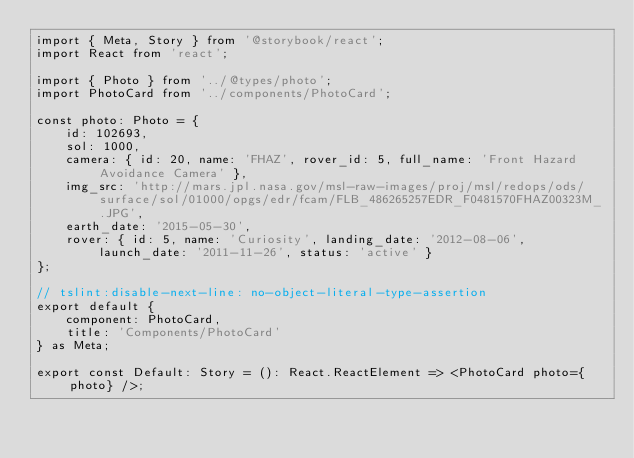<code> <loc_0><loc_0><loc_500><loc_500><_TypeScript_>import { Meta, Story } from '@storybook/react';
import React from 'react';

import { Photo } from '../@types/photo';
import PhotoCard from '../components/PhotoCard';

const photo: Photo = {
    id: 102693,
    sol: 1000,
    camera: { id: 20, name: 'FHAZ', rover_id: 5, full_name: 'Front Hazard Avoidance Camera' },
    img_src: 'http://mars.jpl.nasa.gov/msl-raw-images/proj/msl/redops/ods/surface/sol/01000/opgs/edr/fcam/FLB_486265257EDR_F0481570FHAZ00323M_.JPG',
    earth_date: '2015-05-30',
    rover: { id: 5, name: 'Curiosity', landing_date: '2012-08-06', launch_date: '2011-11-26', status: 'active' }
};

// tslint:disable-next-line: no-object-literal-type-assertion
export default {
    component: PhotoCard,
    title: 'Components/PhotoCard'
} as Meta;

export const Default: Story = (): React.ReactElement => <PhotoCard photo={photo} />;
</code> 